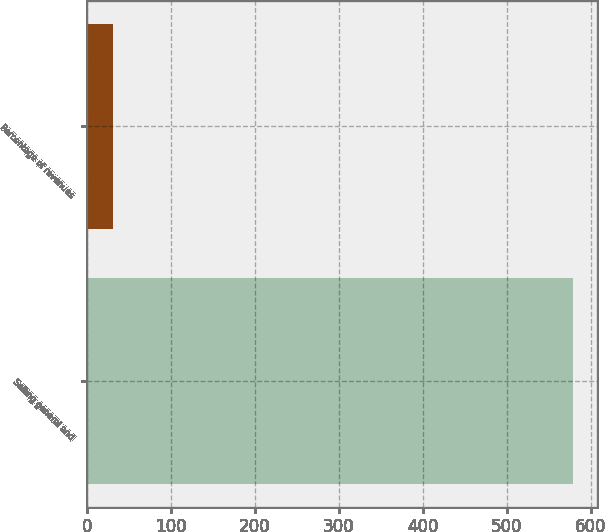Convert chart. <chart><loc_0><loc_0><loc_500><loc_500><bar_chart><fcel>Selling general and<fcel>Percentage of revenues<nl><fcel>578.7<fcel>31.5<nl></chart> 